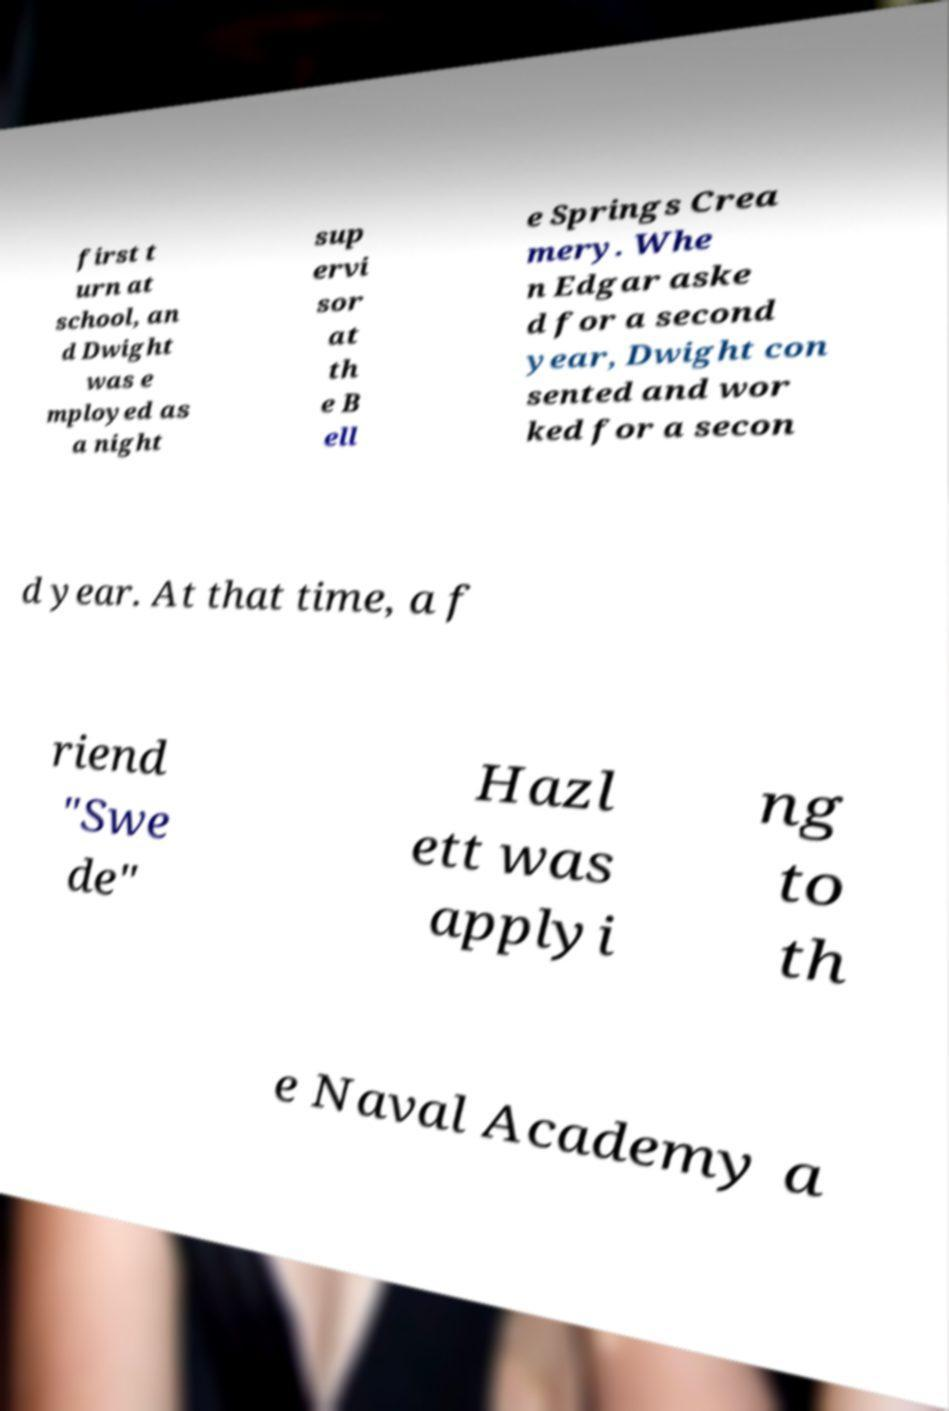Can you accurately transcribe the text from the provided image for me? first t urn at school, an d Dwight was e mployed as a night sup ervi sor at th e B ell e Springs Crea mery. Whe n Edgar aske d for a second year, Dwight con sented and wor ked for a secon d year. At that time, a f riend "Swe de" Hazl ett was applyi ng to th e Naval Academy a 